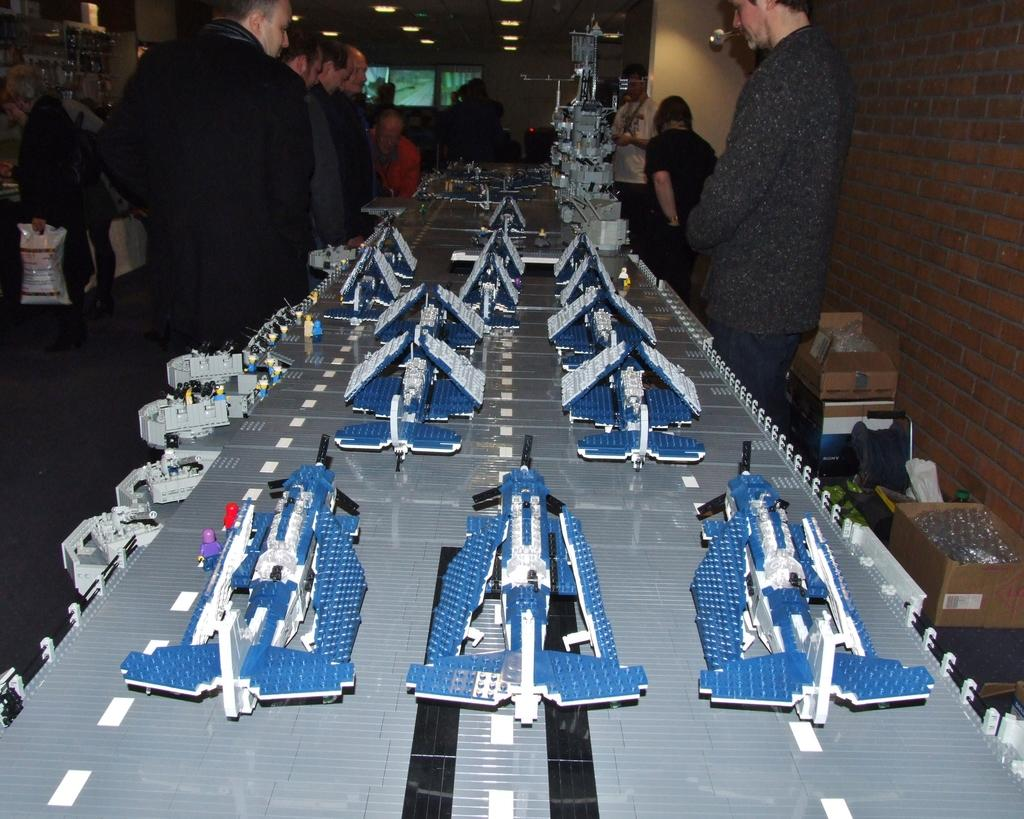What type of toys are on the board in the image? There are Lego toys on a board in the image. What other objects can be seen in the image? Cardboard boxes are present in the image. Can you describe the people in the image? There is a group of people standing in the image. What can be seen providing illumination in the image? Lights are visible in the image. What other items are present in the image besides Lego toys, cardboard boxes, and the group of people? There are other items present in the image. What type of cushion is being used to support the beef in the image? There is no beef or cushion present in the image. 